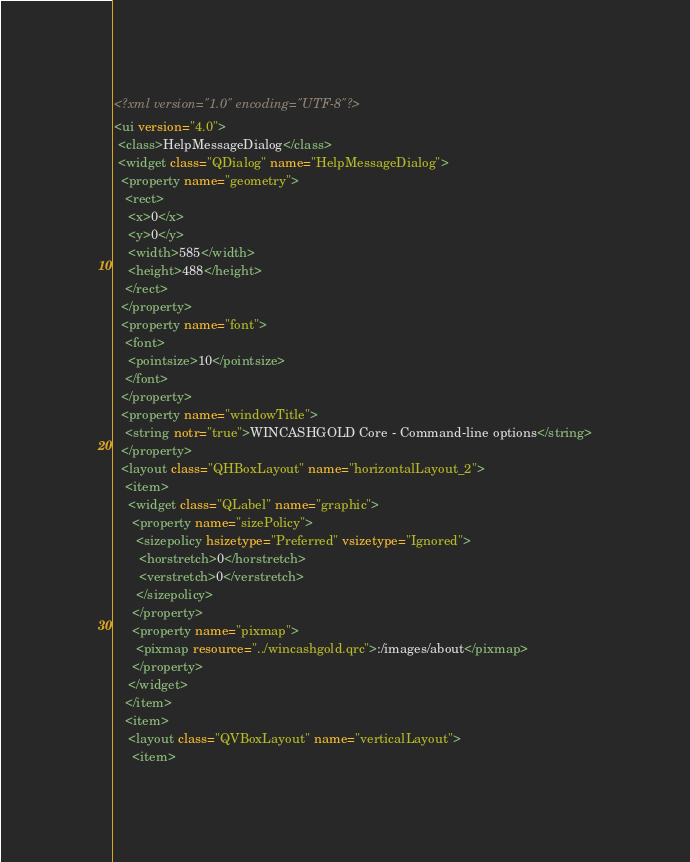Convert code to text. <code><loc_0><loc_0><loc_500><loc_500><_XML_><?xml version="1.0" encoding="UTF-8"?>
<ui version="4.0">
 <class>HelpMessageDialog</class>
 <widget class="QDialog" name="HelpMessageDialog">
  <property name="geometry">
   <rect>
    <x>0</x>
    <y>0</y>
    <width>585</width>
    <height>488</height>
   </rect>
  </property>
  <property name="font">
   <font>
    <pointsize>10</pointsize>
   </font>
  </property>
  <property name="windowTitle">
   <string notr="true">WINCASHGOLD Core - Command-line options</string>
  </property>
  <layout class="QHBoxLayout" name="horizontalLayout_2">
   <item>
    <widget class="QLabel" name="graphic">
     <property name="sizePolicy">
      <sizepolicy hsizetype="Preferred" vsizetype="Ignored">
       <horstretch>0</horstretch>
       <verstretch>0</verstretch>
      </sizepolicy>
     </property>
     <property name="pixmap">
      <pixmap resource="../wincashgold.qrc">:/images/about</pixmap>
     </property>
    </widget>
   </item>
   <item>
    <layout class="QVBoxLayout" name="verticalLayout">
     <item></code> 